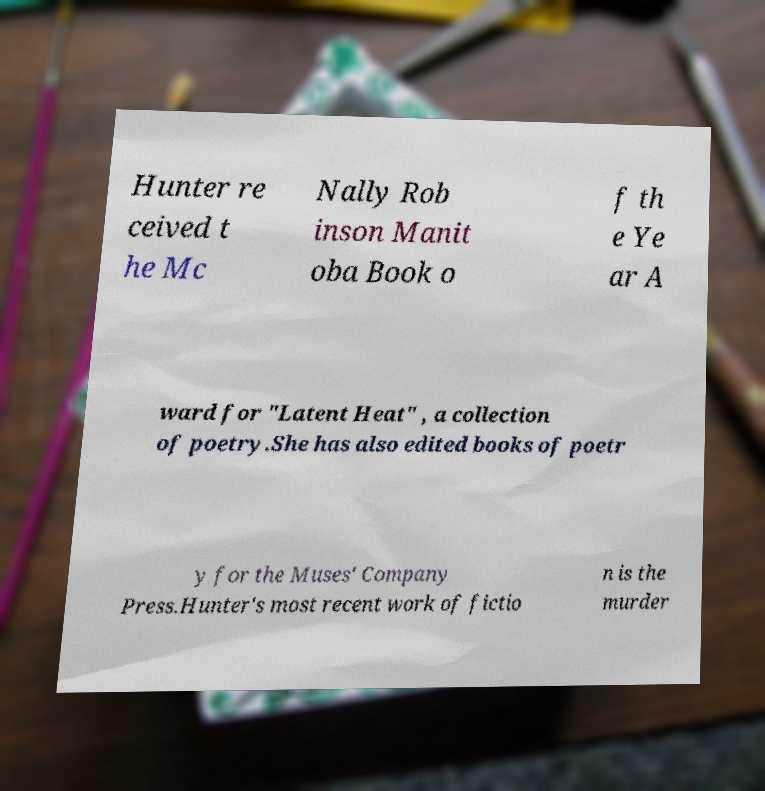Can you read and provide the text displayed in the image?This photo seems to have some interesting text. Can you extract and type it out for me? Hunter re ceived t he Mc Nally Rob inson Manit oba Book o f th e Ye ar A ward for "Latent Heat" , a collection of poetry.She has also edited books of poetr y for the Muses' Company Press.Hunter's most recent work of fictio n is the murder 